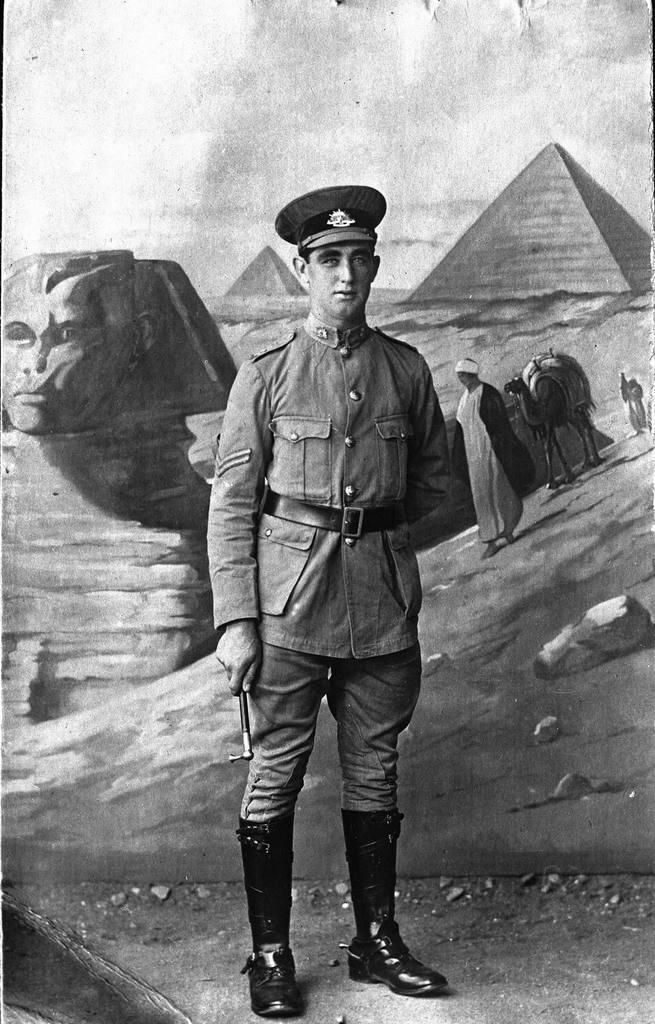Can you describe this image briefly? In this picture I can see there is a man standing, he is wearing a uniform, cap and shoes. In the backdrop there is a poster of pyramids, person walking and there is a camel. This is a black and white picture. 